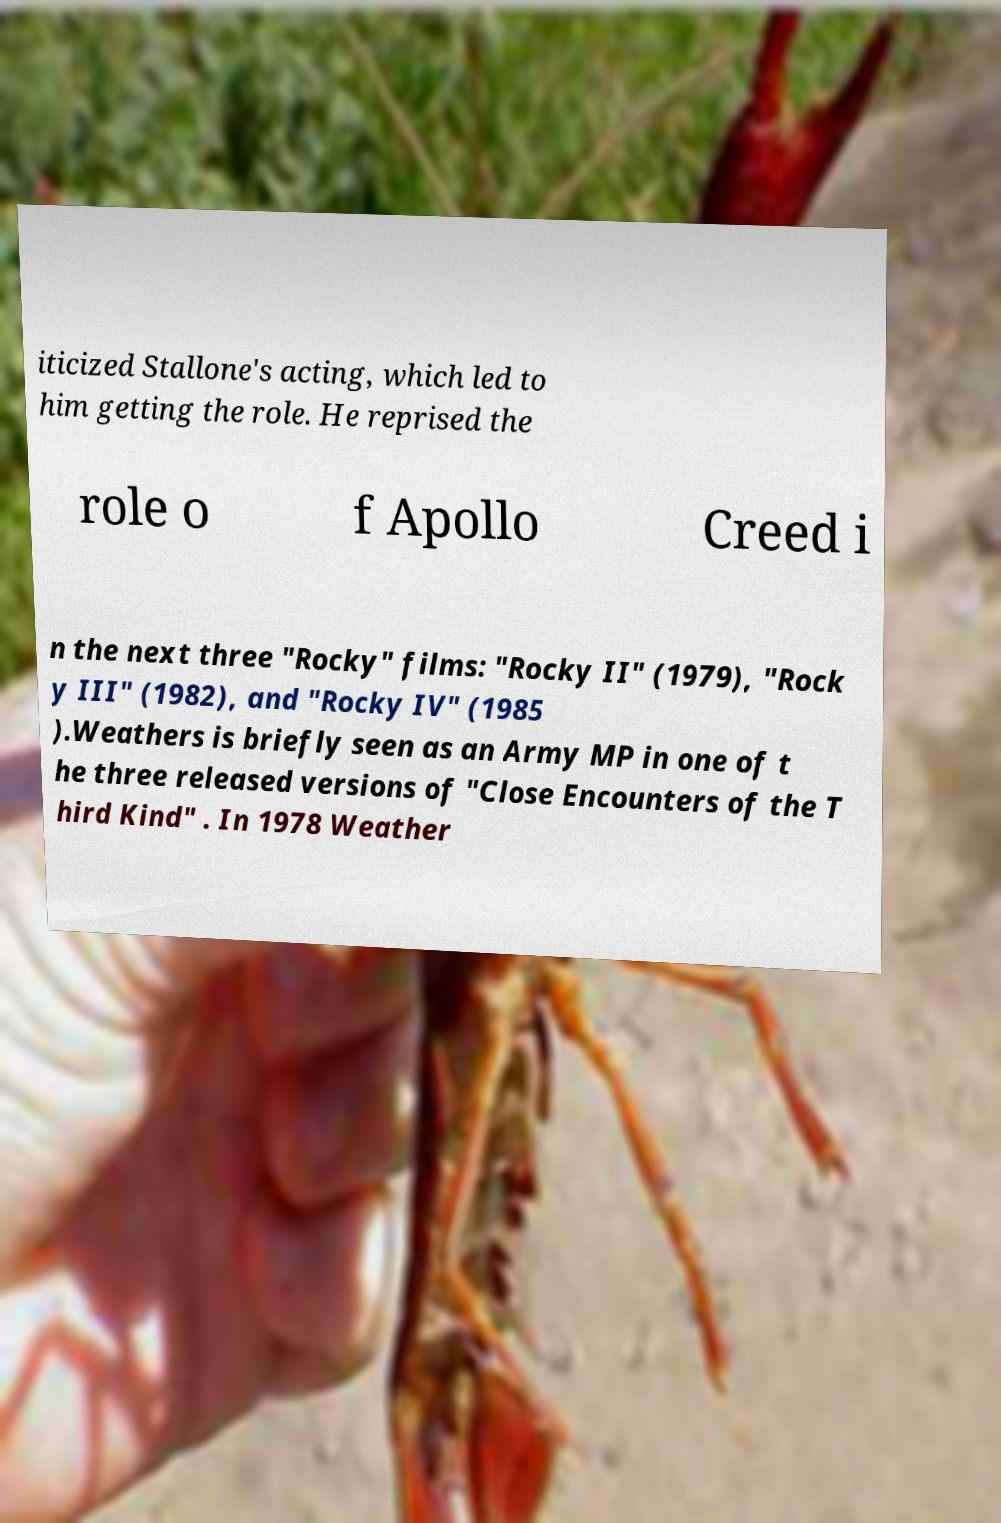What messages or text are displayed in this image? I need them in a readable, typed format. iticized Stallone's acting, which led to him getting the role. He reprised the role o f Apollo Creed i n the next three "Rocky" films: "Rocky II" (1979), "Rock y III" (1982), and "Rocky IV" (1985 ).Weathers is briefly seen as an Army MP in one of t he three released versions of "Close Encounters of the T hird Kind" . In 1978 Weather 